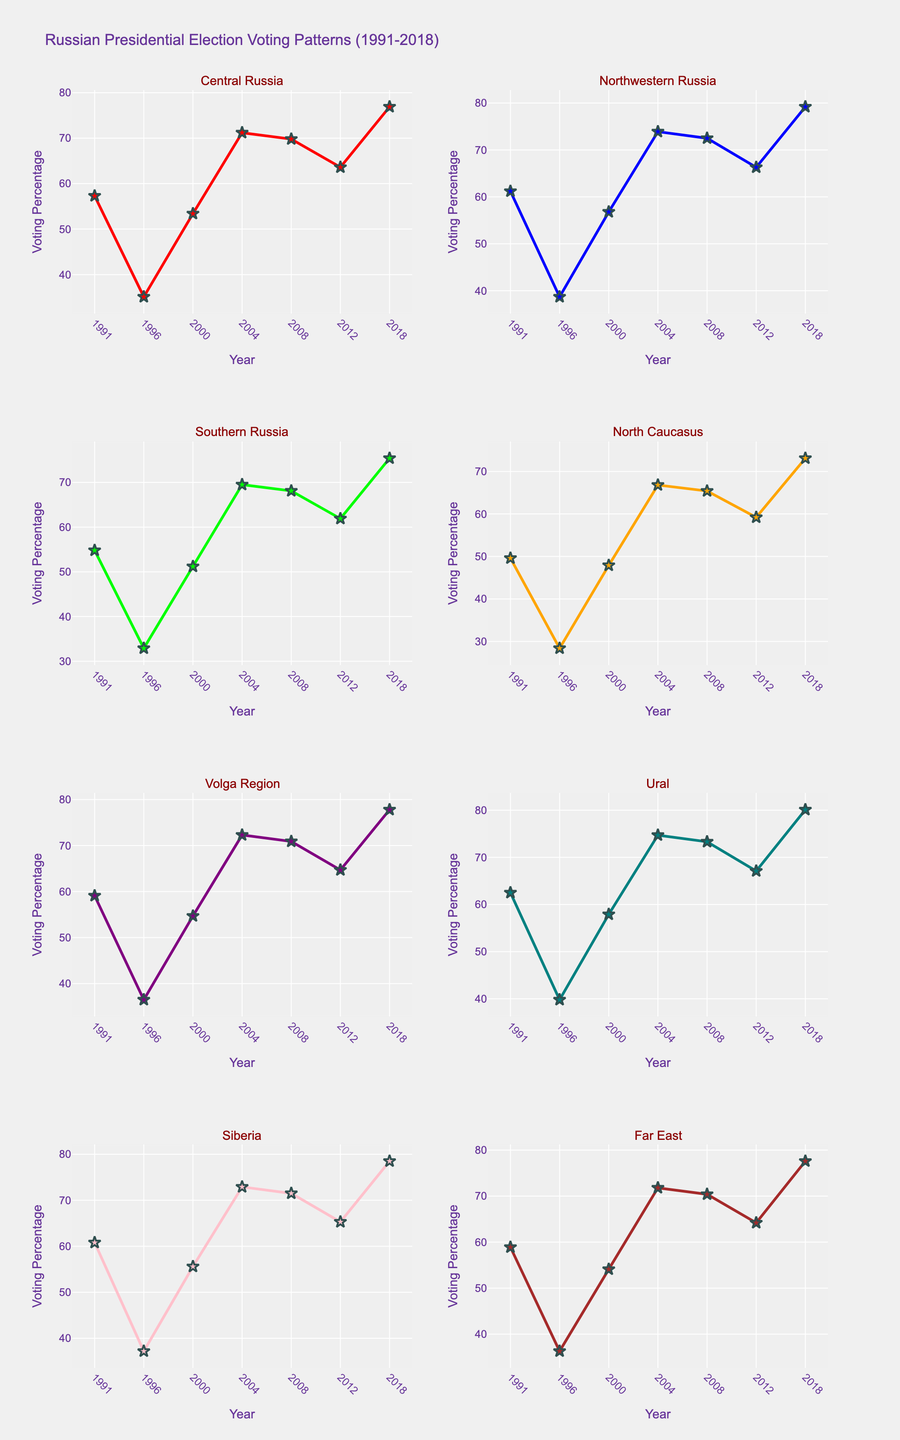What is the title of the figure? The title is clearly located at the top of the figure. It summarizes the content of the plot.
Answer: Russian Presidential Election Voting Patterns (1991-2018) Which region had the highest voting percentage in 2018? Look at the markers for the year 2018 across all subplots. Identify the highest point visually.
Answer: Ural How did the voting percentage for Central Russia change from 1991 to 1996? Locate the data points for Central Russia at the years 1991 and 1996. Compare these values. The percentage decreases from 57.3% in 1991 to 35.1% in 1996.
Answer: Decreased What is the average voting percentage in Siberia over the years? Identify the voting percentages in Siberia for all years. Sum these values and divide by the number of years. (60.8 + 37.2 + 55.6 + 72.9 + 71.5 + 65.3 + 78.5) / 7 = 63.97%.
Answer: 63.97% Which region had the largest increase in voting percentage from 1996 to 2004? Calculate the difference between 2004 and 1996 for each region, then determine which region has the largest positive change. Ural: (74.7 - 39.8) = 34.9, which is the highest.
Answer: Ural In which year did Far East experience the lowest voting percentage? Identify the lowest point in the Far East subplot and note the corresponding year.
Answer: 1996 Compare the voting percentage of Volga Region and North Caucasus in 2008. Which was higher? Look at the markers for both regions in the year 2008 and compare their values. Volga Region is 70.9% and North Caucasus is 65.4%.
Answer: Volga Region How many subplots are there in the figure? Count the number of individual region plots displayed in the figure.
Answer: 8 Which region consistently had over 70% voting percentage from 2004 to 2018? Check each subplot for regions where the voting percentage remains above 70% over the years 2004, 2008, 2012, and 2018. Ural maintains above 70% in all these years.
Answer: Ural Is the trend in Southern Russia's voting percentage from 1991 to 2018 generally increasing or decreasing? Observe the overall direction of data points in the Southern Russia subplot. Initially, there's a decrease but then an increase towards 2018. The overall trend is increasing.
Answer: Increasing 